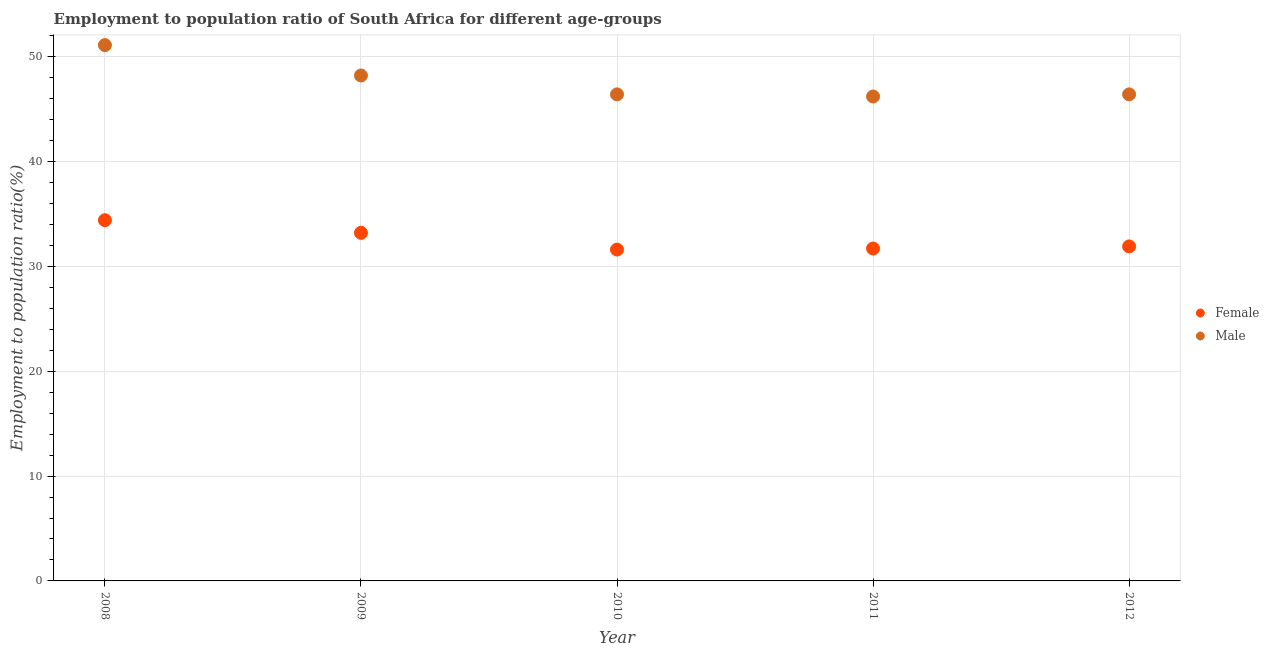Is the number of dotlines equal to the number of legend labels?
Your answer should be compact. Yes. What is the employment to population ratio(male) in 2009?
Provide a succinct answer. 48.2. Across all years, what is the maximum employment to population ratio(male)?
Offer a very short reply. 51.1. Across all years, what is the minimum employment to population ratio(male)?
Your answer should be very brief. 46.2. In which year was the employment to population ratio(male) maximum?
Provide a succinct answer. 2008. What is the total employment to population ratio(male) in the graph?
Your response must be concise. 238.3. What is the difference between the employment to population ratio(male) in 2011 and that in 2012?
Provide a succinct answer. -0.2. What is the difference between the employment to population ratio(male) in 2011 and the employment to population ratio(female) in 2008?
Ensure brevity in your answer.  11.8. What is the average employment to population ratio(male) per year?
Offer a terse response. 47.66. In the year 2010, what is the difference between the employment to population ratio(male) and employment to population ratio(female)?
Your answer should be compact. 14.8. What is the ratio of the employment to population ratio(male) in 2010 to that in 2011?
Offer a terse response. 1. What is the difference between the highest and the second highest employment to population ratio(male)?
Keep it short and to the point. 2.9. What is the difference between the highest and the lowest employment to population ratio(female)?
Ensure brevity in your answer.  2.8. Is the sum of the employment to population ratio(male) in 2008 and 2012 greater than the maximum employment to population ratio(female) across all years?
Your answer should be compact. Yes. Does the employment to population ratio(male) monotonically increase over the years?
Your answer should be compact. No. Is the employment to population ratio(female) strictly greater than the employment to population ratio(male) over the years?
Ensure brevity in your answer.  No. How many dotlines are there?
Your answer should be very brief. 2. How many years are there in the graph?
Keep it short and to the point. 5. What is the difference between two consecutive major ticks on the Y-axis?
Keep it short and to the point. 10. Are the values on the major ticks of Y-axis written in scientific E-notation?
Your answer should be very brief. No. Does the graph contain any zero values?
Offer a terse response. No. How are the legend labels stacked?
Your answer should be very brief. Vertical. What is the title of the graph?
Give a very brief answer. Employment to population ratio of South Africa for different age-groups. Does "Primary education" appear as one of the legend labels in the graph?
Ensure brevity in your answer.  No. What is the label or title of the X-axis?
Your answer should be compact. Year. What is the label or title of the Y-axis?
Your response must be concise. Employment to population ratio(%). What is the Employment to population ratio(%) in Female in 2008?
Your answer should be compact. 34.4. What is the Employment to population ratio(%) of Male in 2008?
Make the answer very short. 51.1. What is the Employment to population ratio(%) of Female in 2009?
Offer a terse response. 33.2. What is the Employment to population ratio(%) of Male in 2009?
Give a very brief answer. 48.2. What is the Employment to population ratio(%) in Female in 2010?
Your answer should be compact. 31.6. What is the Employment to population ratio(%) of Male in 2010?
Your answer should be very brief. 46.4. What is the Employment to population ratio(%) of Female in 2011?
Your answer should be compact. 31.7. What is the Employment to population ratio(%) of Male in 2011?
Keep it short and to the point. 46.2. What is the Employment to population ratio(%) in Female in 2012?
Your answer should be very brief. 31.9. What is the Employment to population ratio(%) in Male in 2012?
Ensure brevity in your answer.  46.4. Across all years, what is the maximum Employment to population ratio(%) in Female?
Give a very brief answer. 34.4. Across all years, what is the maximum Employment to population ratio(%) of Male?
Provide a succinct answer. 51.1. Across all years, what is the minimum Employment to population ratio(%) of Female?
Your response must be concise. 31.6. Across all years, what is the minimum Employment to population ratio(%) of Male?
Your response must be concise. 46.2. What is the total Employment to population ratio(%) of Female in the graph?
Your response must be concise. 162.8. What is the total Employment to population ratio(%) of Male in the graph?
Your answer should be compact. 238.3. What is the difference between the Employment to population ratio(%) in Female in 2008 and that in 2011?
Your response must be concise. 2.7. What is the difference between the Employment to population ratio(%) in Male in 2008 and that in 2011?
Keep it short and to the point. 4.9. What is the difference between the Employment to population ratio(%) in Female in 2008 and that in 2012?
Your answer should be compact. 2.5. What is the difference between the Employment to population ratio(%) of Male in 2008 and that in 2012?
Your response must be concise. 4.7. What is the difference between the Employment to population ratio(%) in Female in 2009 and that in 2011?
Provide a short and direct response. 1.5. What is the difference between the Employment to population ratio(%) in Male in 2009 and that in 2011?
Your answer should be compact. 2. What is the difference between the Employment to population ratio(%) of Female in 2009 and that in 2012?
Provide a succinct answer. 1.3. What is the difference between the Employment to population ratio(%) of Male in 2010 and that in 2011?
Ensure brevity in your answer.  0.2. What is the difference between the Employment to population ratio(%) of Female in 2010 and that in 2012?
Offer a very short reply. -0.3. What is the difference between the Employment to population ratio(%) in Male in 2010 and that in 2012?
Your response must be concise. 0. What is the difference between the Employment to population ratio(%) of Male in 2011 and that in 2012?
Your answer should be very brief. -0.2. What is the difference between the Employment to population ratio(%) of Female in 2008 and the Employment to population ratio(%) of Male in 2011?
Your answer should be very brief. -11.8. What is the difference between the Employment to population ratio(%) of Female in 2009 and the Employment to population ratio(%) of Male in 2010?
Keep it short and to the point. -13.2. What is the difference between the Employment to population ratio(%) in Female in 2009 and the Employment to population ratio(%) in Male in 2012?
Make the answer very short. -13.2. What is the difference between the Employment to population ratio(%) of Female in 2010 and the Employment to population ratio(%) of Male in 2011?
Make the answer very short. -14.6. What is the difference between the Employment to population ratio(%) in Female in 2010 and the Employment to population ratio(%) in Male in 2012?
Offer a very short reply. -14.8. What is the difference between the Employment to population ratio(%) of Female in 2011 and the Employment to population ratio(%) of Male in 2012?
Your response must be concise. -14.7. What is the average Employment to population ratio(%) in Female per year?
Keep it short and to the point. 32.56. What is the average Employment to population ratio(%) of Male per year?
Make the answer very short. 47.66. In the year 2008, what is the difference between the Employment to population ratio(%) of Female and Employment to population ratio(%) of Male?
Give a very brief answer. -16.7. In the year 2009, what is the difference between the Employment to population ratio(%) in Female and Employment to population ratio(%) in Male?
Provide a succinct answer. -15. In the year 2010, what is the difference between the Employment to population ratio(%) of Female and Employment to population ratio(%) of Male?
Your answer should be compact. -14.8. What is the ratio of the Employment to population ratio(%) in Female in 2008 to that in 2009?
Your answer should be compact. 1.04. What is the ratio of the Employment to population ratio(%) of Male in 2008 to that in 2009?
Ensure brevity in your answer.  1.06. What is the ratio of the Employment to population ratio(%) in Female in 2008 to that in 2010?
Your response must be concise. 1.09. What is the ratio of the Employment to population ratio(%) in Male in 2008 to that in 2010?
Your answer should be compact. 1.1. What is the ratio of the Employment to population ratio(%) of Female in 2008 to that in 2011?
Give a very brief answer. 1.09. What is the ratio of the Employment to population ratio(%) of Male in 2008 to that in 2011?
Give a very brief answer. 1.11. What is the ratio of the Employment to population ratio(%) in Female in 2008 to that in 2012?
Provide a succinct answer. 1.08. What is the ratio of the Employment to population ratio(%) of Male in 2008 to that in 2012?
Give a very brief answer. 1.1. What is the ratio of the Employment to population ratio(%) of Female in 2009 to that in 2010?
Make the answer very short. 1.05. What is the ratio of the Employment to population ratio(%) in Male in 2009 to that in 2010?
Provide a short and direct response. 1.04. What is the ratio of the Employment to population ratio(%) of Female in 2009 to that in 2011?
Your response must be concise. 1.05. What is the ratio of the Employment to population ratio(%) of Male in 2009 to that in 2011?
Offer a terse response. 1.04. What is the ratio of the Employment to population ratio(%) in Female in 2009 to that in 2012?
Make the answer very short. 1.04. What is the ratio of the Employment to population ratio(%) of Male in 2009 to that in 2012?
Provide a short and direct response. 1.04. What is the ratio of the Employment to population ratio(%) of Female in 2010 to that in 2011?
Keep it short and to the point. 1. What is the ratio of the Employment to population ratio(%) of Male in 2010 to that in 2011?
Your response must be concise. 1. What is the ratio of the Employment to population ratio(%) of Female in 2010 to that in 2012?
Provide a short and direct response. 0.99. What is the ratio of the Employment to population ratio(%) in Female in 2011 to that in 2012?
Your response must be concise. 0.99. What is the ratio of the Employment to population ratio(%) of Male in 2011 to that in 2012?
Your response must be concise. 1. What is the difference between the highest and the second highest Employment to population ratio(%) in Female?
Offer a very short reply. 1.2. What is the difference between the highest and the lowest Employment to population ratio(%) in Female?
Your answer should be very brief. 2.8. What is the difference between the highest and the lowest Employment to population ratio(%) in Male?
Your response must be concise. 4.9. 